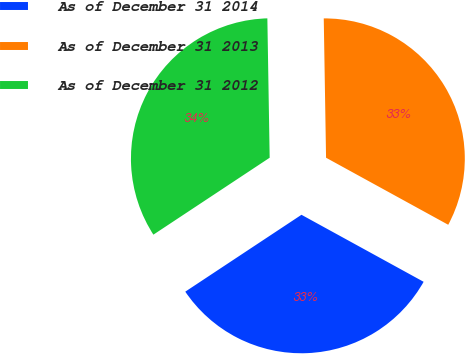Convert chart. <chart><loc_0><loc_0><loc_500><loc_500><pie_chart><fcel>As of December 31 2014<fcel>As of December 31 2013<fcel>As of December 31 2012<nl><fcel>32.71%<fcel>33.25%<fcel>34.04%<nl></chart> 